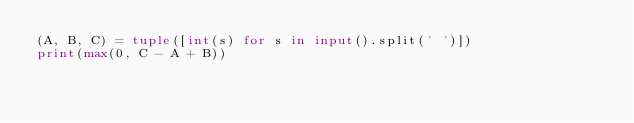Convert code to text. <code><loc_0><loc_0><loc_500><loc_500><_Python_>(A, B, C) = tuple([int(s) for s in input().split(' ')])
print(max(0, C - A + B))</code> 